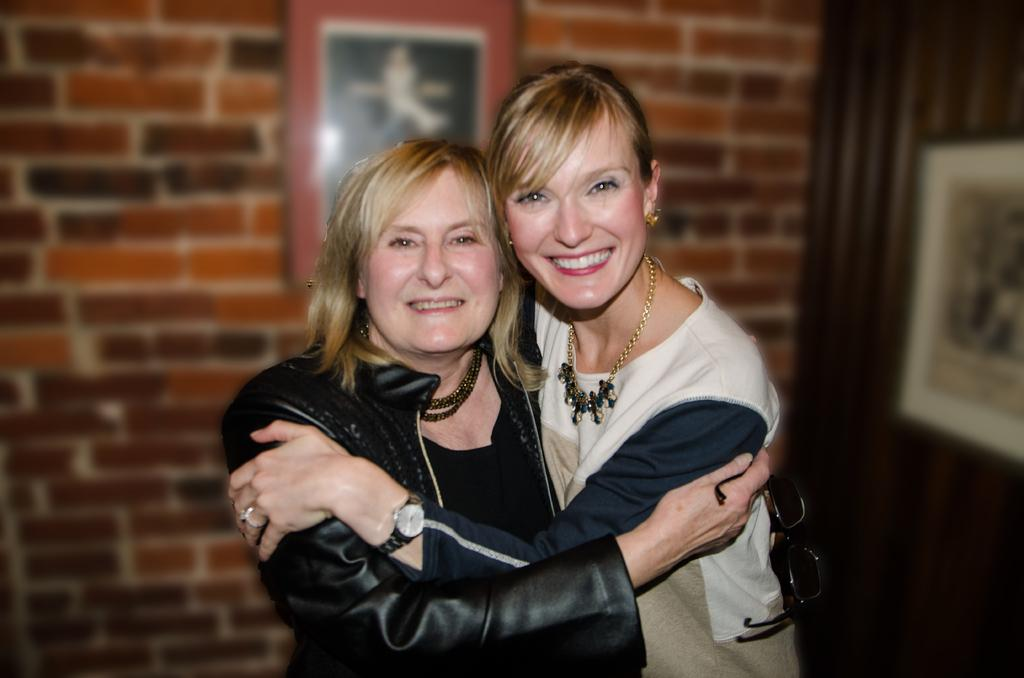How many women are in the image? There are two women in the foreground of the image. What are the women doing in the image? The women are hugging each other. What can be seen in the background of the image? There are photo frames, a wall, and a door in the background of the image. What rule is being broken by the cows in the image? There are no cows present in the image, so no rules can be broken by them. 